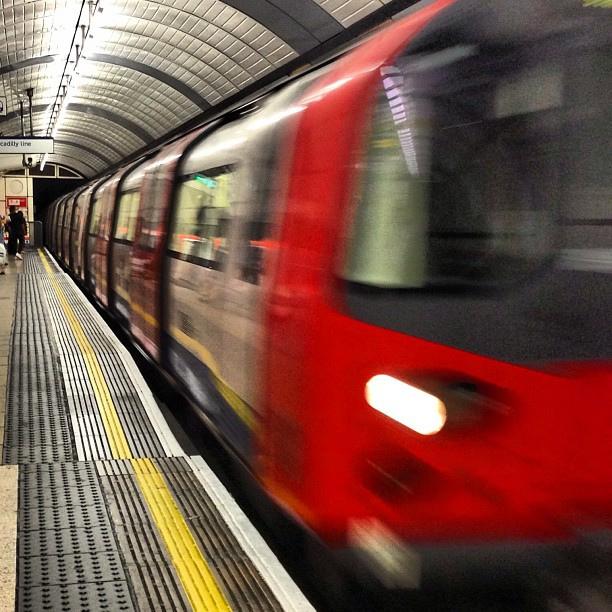What is the red thing on the right?
Give a very brief answer. Train. Where is this taken?
Be succinct. Train station. Does the train have lights?
Be succinct. Yes. 